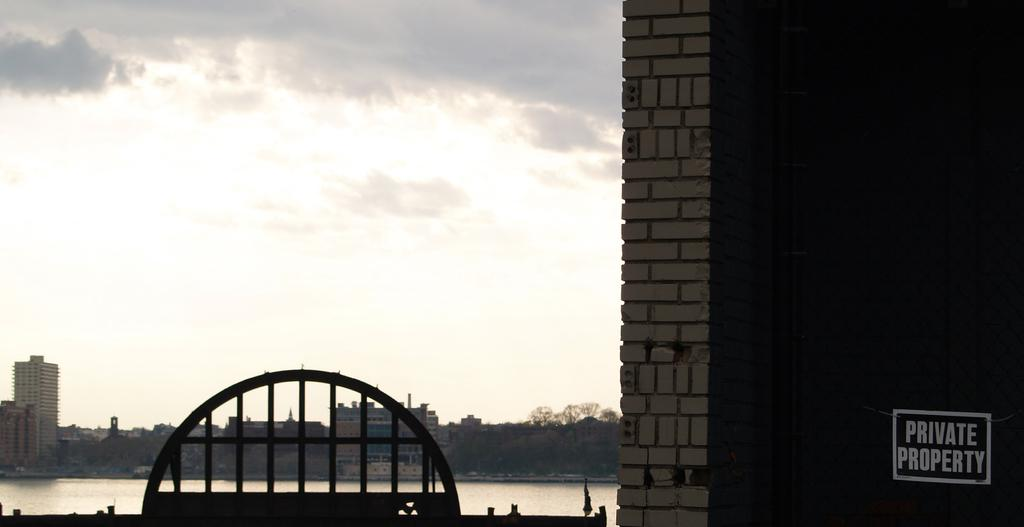<image>
Give a short and clear explanation of the subsequent image. A view of a lake from a piece of private property. 